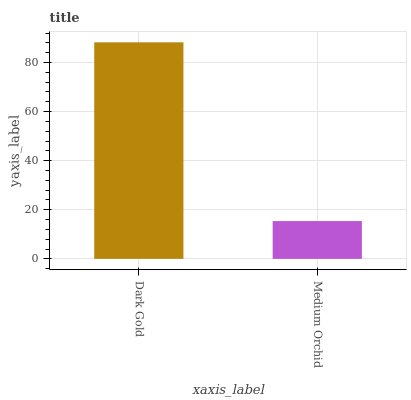Is Medium Orchid the maximum?
Answer yes or no. No. Is Dark Gold greater than Medium Orchid?
Answer yes or no. Yes. Is Medium Orchid less than Dark Gold?
Answer yes or no. Yes. Is Medium Orchid greater than Dark Gold?
Answer yes or no. No. Is Dark Gold less than Medium Orchid?
Answer yes or no. No. Is Dark Gold the high median?
Answer yes or no. Yes. Is Medium Orchid the low median?
Answer yes or no. Yes. Is Medium Orchid the high median?
Answer yes or no. No. Is Dark Gold the low median?
Answer yes or no. No. 